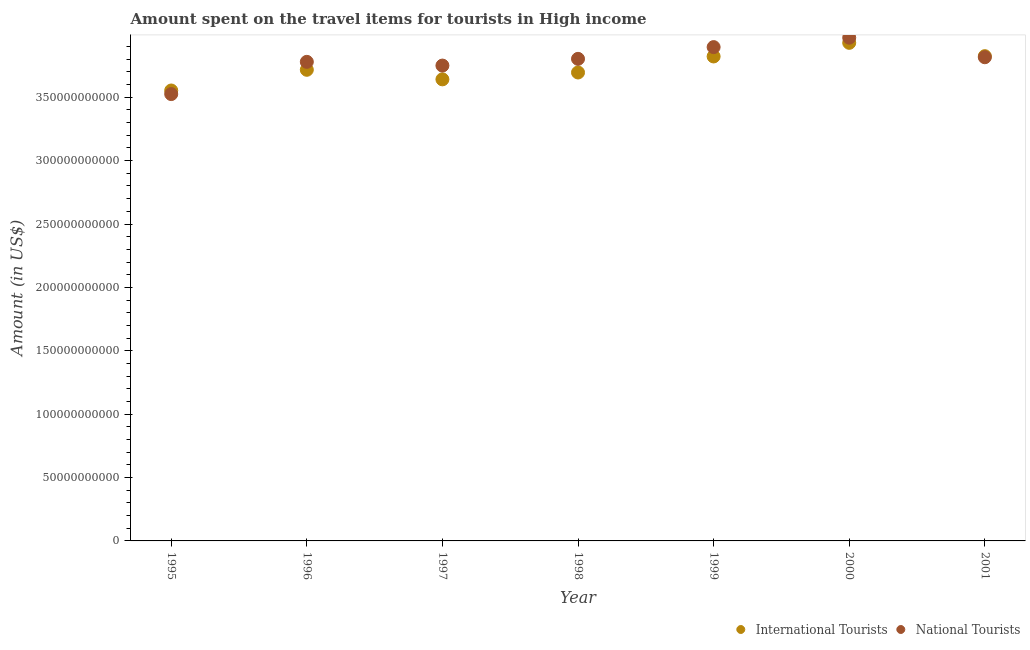How many different coloured dotlines are there?
Provide a short and direct response. 2. Is the number of dotlines equal to the number of legend labels?
Provide a short and direct response. Yes. What is the amount spent on travel items of international tourists in 2000?
Provide a short and direct response. 3.93e+11. Across all years, what is the maximum amount spent on travel items of national tourists?
Give a very brief answer. 3.97e+11. Across all years, what is the minimum amount spent on travel items of national tourists?
Provide a short and direct response. 3.52e+11. In which year was the amount spent on travel items of national tourists minimum?
Give a very brief answer. 1995. What is the total amount spent on travel items of national tourists in the graph?
Your answer should be very brief. 2.65e+12. What is the difference between the amount spent on travel items of international tourists in 1996 and that in 2001?
Make the answer very short. -1.08e+1. What is the difference between the amount spent on travel items of international tourists in 1999 and the amount spent on travel items of national tourists in 1998?
Your answer should be compact. 1.89e+09. What is the average amount spent on travel items of national tourists per year?
Your response must be concise. 3.79e+11. In the year 1998, what is the difference between the amount spent on travel items of international tourists and amount spent on travel items of national tourists?
Offer a very short reply. -1.08e+1. In how many years, is the amount spent on travel items of national tourists greater than 310000000000 US$?
Offer a terse response. 7. What is the ratio of the amount spent on travel items of national tourists in 1999 to that in 2000?
Provide a short and direct response. 0.98. Is the difference between the amount spent on travel items of national tourists in 1995 and 2001 greater than the difference between the amount spent on travel items of international tourists in 1995 and 2001?
Give a very brief answer. No. What is the difference between the highest and the second highest amount spent on travel items of international tourists?
Provide a short and direct response. 1.05e+1. What is the difference between the highest and the lowest amount spent on travel items of national tourists?
Your answer should be very brief. 4.45e+1. Is the sum of the amount spent on travel items of international tourists in 1999 and 2001 greater than the maximum amount spent on travel items of national tourists across all years?
Your answer should be very brief. Yes. Does the amount spent on travel items of international tourists monotonically increase over the years?
Offer a very short reply. No. Is the amount spent on travel items of national tourists strictly greater than the amount spent on travel items of international tourists over the years?
Offer a terse response. No. Is the amount spent on travel items of international tourists strictly less than the amount spent on travel items of national tourists over the years?
Your response must be concise. No. How many dotlines are there?
Give a very brief answer. 2. What is the difference between two consecutive major ticks on the Y-axis?
Ensure brevity in your answer.  5.00e+1. Are the values on the major ticks of Y-axis written in scientific E-notation?
Ensure brevity in your answer.  No. Does the graph contain any zero values?
Your answer should be very brief. No. Does the graph contain grids?
Offer a very short reply. No. How are the legend labels stacked?
Give a very brief answer. Horizontal. What is the title of the graph?
Give a very brief answer. Amount spent on the travel items for tourists in High income. What is the Amount (in US$) in International Tourists in 1995?
Your response must be concise. 3.55e+11. What is the Amount (in US$) in National Tourists in 1995?
Offer a very short reply. 3.52e+11. What is the Amount (in US$) of International Tourists in 1996?
Keep it short and to the point. 3.72e+11. What is the Amount (in US$) in National Tourists in 1996?
Your response must be concise. 3.78e+11. What is the Amount (in US$) in International Tourists in 1997?
Offer a very short reply. 3.64e+11. What is the Amount (in US$) of National Tourists in 1997?
Your answer should be very brief. 3.75e+11. What is the Amount (in US$) of International Tourists in 1998?
Your answer should be very brief. 3.70e+11. What is the Amount (in US$) of National Tourists in 1998?
Provide a succinct answer. 3.80e+11. What is the Amount (in US$) of International Tourists in 1999?
Your response must be concise. 3.82e+11. What is the Amount (in US$) in National Tourists in 1999?
Your response must be concise. 3.90e+11. What is the Amount (in US$) of International Tourists in 2000?
Your answer should be very brief. 3.93e+11. What is the Amount (in US$) in National Tourists in 2000?
Provide a short and direct response. 3.97e+11. What is the Amount (in US$) of International Tourists in 2001?
Your answer should be very brief. 3.82e+11. What is the Amount (in US$) of National Tourists in 2001?
Keep it short and to the point. 3.82e+11. Across all years, what is the maximum Amount (in US$) of International Tourists?
Your response must be concise. 3.93e+11. Across all years, what is the maximum Amount (in US$) in National Tourists?
Your answer should be very brief. 3.97e+11. Across all years, what is the minimum Amount (in US$) of International Tourists?
Make the answer very short. 3.55e+11. Across all years, what is the minimum Amount (in US$) in National Tourists?
Provide a succinct answer. 3.52e+11. What is the total Amount (in US$) of International Tourists in the graph?
Offer a very short reply. 2.62e+12. What is the total Amount (in US$) in National Tourists in the graph?
Your answer should be compact. 2.65e+12. What is the difference between the Amount (in US$) in International Tourists in 1995 and that in 1996?
Offer a very short reply. -1.63e+1. What is the difference between the Amount (in US$) in National Tourists in 1995 and that in 1996?
Ensure brevity in your answer.  -2.54e+1. What is the difference between the Amount (in US$) of International Tourists in 1995 and that in 1997?
Provide a short and direct response. -8.79e+09. What is the difference between the Amount (in US$) of National Tourists in 1995 and that in 1997?
Keep it short and to the point. -2.25e+1. What is the difference between the Amount (in US$) of International Tourists in 1995 and that in 1998?
Keep it short and to the point. -1.42e+1. What is the difference between the Amount (in US$) in National Tourists in 1995 and that in 1998?
Your answer should be compact. -2.78e+1. What is the difference between the Amount (in US$) in International Tourists in 1995 and that in 1999?
Your answer should be very brief. -2.68e+1. What is the difference between the Amount (in US$) in National Tourists in 1995 and that in 1999?
Provide a short and direct response. -3.71e+1. What is the difference between the Amount (in US$) of International Tourists in 1995 and that in 2000?
Keep it short and to the point. -3.76e+1. What is the difference between the Amount (in US$) in National Tourists in 1995 and that in 2000?
Offer a very short reply. -4.45e+1. What is the difference between the Amount (in US$) of International Tourists in 1995 and that in 2001?
Ensure brevity in your answer.  -2.71e+1. What is the difference between the Amount (in US$) in National Tourists in 1995 and that in 2001?
Your answer should be very brief. -2.91e+1. What is the difference between the Amount (in US$) in International Tourists in 1996 and that in 1997?
Offer a very short reply. 7.54e+09. What is the difference between the Amount (in US$) in National Tourists in 1996 and that in 1997?
Your answer should be compact. 2.94e+09. What is the difference between the Amount (in US$) of International Tourists in 1996 and that in 1998?
Your response must be concise. 2.13e+09. What is the difference between the Amount (in US$) in National Tourists in 1996 and that in 1998?
Ensure brevity in your answer.  -2.36e+09. What is the difference between the Amount (in US$) in International Tourists in 1996 and that in 1999?
Offer a very short reply. -1.05e+1. What is the difference between the Amount (in US$) in National Tourists in 1996 and that in 1999?
Your answer should be compact. -1.16e+1. What is the difference between the Amount (in US$) of International Tourists in 1996 and that in 2000?
Provide a succinct answer. -2.13e+1. What is the difference between the Amount (in US$) of National Tourists in 1996 and that in 2000?
Make the answer very short. -1.91e+1. What is the difference between the Amount (in US$) in International Tourists in 1996 and that in 2001?
Your response must be concise. -1.08e+1. What is the difference between the Amount (in US$) in National Tourists in 1996 and that in 2001?
Keep it short and to the point. -3.64e+09. What is the difference between the Amount (in US$) of International Tourists in 1997 and that in 1998?
Provide a short and direct response. -5.41e+09. What is the difference between the Amount (in US$) in National Tourists in 1997 and that in 1998?
Your answer should be very brief. -5.30e+09. What is the difference between the Amount (in US$) in International Tourists in 1997 and that in 1999?
Your answer should be very brief. -1.81e+1. What is the difference between the Amount (in US$) in National Tourists in 1997 and that in 1999?
Offer a very short reply. -1.46e+1. What is the difference between the Amount (in US$) in International Tourists in 1997 and that in 2000?
Offer a terse response. -2.88e+1. What is the difference between the Amount (in US$) in National Tourists in 1997 and that in 2000?
Provide a succinct answer. -2.20e+1. What is the difference between the Amount (in US$) in International Tourists in 1997 and that in 2001?
Your answer should be very brief. -1.83e+1. What is the difference between the Amount (in US$) of National Tourists in 1997 and that in 2001?
Give a very brief answer. -6.58e+09. What is the difference between the Amount (in US$) in International Tourists in 1998 and that in 1999?
Provide a short and direct response. -1.26e+1. What is the difference between the Amount (in US$) of National Tourists in 1998 and that in 1999?
Offer a terse response. -9.26e+09. What is the difference between the Amount (in US$) of International Tourists in 1998 and that in 2000?
Give a very brief answer. -2.34e+1. What is the difference between the Amount (in US$) in National Tourists in 1998 and that in 2000?
Ensure brevity in your answer.  -1.67e+1. What is the difference between the Amount (in US$) of International Tourists in 1998 and that in 2001?
Provide a short and direct response. -1.29e+1. What is the difference between the Amount (in US$) in National Tourists in 1998 and that in 2001?
Ensure brevity in your answer.  -1.28e+09. What is the difference between the Amount (in US$) in International Tourists in 1999 and that in 2000?
Your answer should be very brief. -1.07e+1. What is the difference between the Amount (in US$) of National Tourists in 1999 and that in 2000?
Make the answer very short. -7.43e+09. What is the difference between the Amount (in US$) in International Tourists in 1999 and that in 2001?
Keep it short and to the point. -2.35e+08. What is the difference between the Amount (in US$) in National Tourists in 1999 and that in 2001?
Your response must be concise. 7.99e+09. What is the difference between the Amount (in US$) of International Tourists in 2000 and that in 2001?
Provide a short and direct response. 1.05e+1. What is the difference between the Amount (in US$) of National Tourists in 2000 and that in 2001?
Provide a succinct answer. 1.54e+1. What is the difference between the Amount (in US$) of International Tourists in 1995 and the Amount (in US$) of National Tourists in 1996?
Provide a succinct answer. -2.26e+1. What is the difference between the Amount (in US$) of International Tourists in 1995 and the Amount (in US$) of National Tourists in 1997?
Offer a very short reply. -1.97e+1. What is the difference between the Amount (in US$) of International Tourists in 1995 and the Amount (in US$) of National Tourists in 1998?
Provide a succinct answer. -2.50e+1. What is the difference between the Amount (in US$) in International Tourists in 1995 and the Amount (in US$) in National Tourists in 1999?
Keep it short and to the point. -3.42e+1. What is the difference between the Amount (in US$) in International Tourists in 1995 and the Amount (in US$) in National Tourists in 2000?
Keep it short and to the point. -4.17e+1. What is the difference between the Amount (in US$) in International Tourists in 1995 and the Amount (in US$) in National Tourists in 2001?
Keep it short and to the point. -2.62e+1. What is the difference between the Amount (in US$) in International Tourists in 1996 and the Amount (in US$) in National Tourists in 1997?
Offer a very short reply. -3.33e+09. What is the difference between the Amount (in US$) of International Tourists in 1996 and the Amount (in US$) of National Tourists in 1998?
Your answer should be very brief. -8.63e+09. What is the difference between the Amount (in US$) of International Tourists in 1996 and the Amount (in US$) of National Tourists in 1999?
Your answer should be very brief. -1.79e+1. What is the difference between the Amount (in US$) of International Tourists in 1996 and the Amount (in US$) of National Tourists in 2000?
Provide a short and direct response. -2.53e+1. What is the difference between the Amount (in US$) of International Tourists in 1996 and the Amount (in US$) of National Tourists in 2001?
Your response must be concise. -9.91e+09. What is the difference between the Amount (in US$) of International Tourists in 1997 and the Amount (in US$) of National Tourists in 1998?
Offer a very short reply. -1.62e+1. What is the difference between the Amount (in US$) in International Tourists in 1997 and the Amount (in US$) in National Tourists in 1999?
Your answer should be very brief. -2.54e+1. What is the difference between the Amount (in US$) in International Tourists in 1997 and the Amount (in US$) in National Tourists in 2000?
Provide a succinct answer. -3.29e+1. What is the difference between the Amount (in US$) in International Tourists in 1997 and the Amount (in US$) in National Tourists in 2001?
Give a very brief answer. -1.74e+1. What is the difference between the Amount (in US$) of International Tourists in 1998 and the Amount (in US$) of National Tourists in 1999?
Provide a short and direct response. -2.00e+1. What is the difference between the Amount (in US$) of International Tourists in 1998 and the Amount (in US$) of National Tourists in 2000?
Make the answer very short. -2.75e+1. What is the difference between the Amount (in US$) of International Tourists in 1998 and the Amount (in US$) of National Tourists in 2001?
Provide a short and direct response. -1.20e+1. What is the difference between the Amount (in US$) of International Tourists in 1999 and the Amount (in US$) of National Tourists in 2000?
Your answer should be very brief. -1.48e+1. What is the difference between the Amount (in US$) of International Tourists in 1999 and the Amount (in US$) of National Tourists in 2001?
Offer a terse response. 6.11e+08. What is the difference between the Amount (in US$) in International Tourists in 2000 and the Amount (in US$) in National Tourists in 2001?
Make the answer very short. 1.14e+1. What is the average Amount (in US$) of International Tourists per year?
Make the answer very short. 3.74e+11. What is the average Amount (in US$) of National Tourists per year?
Your response must be concise. 3.79e+11. In the year 1995, what is the difference between the Amount (in US$) in International Tourists and Amount (in US$) in National Tourists?
Your answer should be compact. 2.83e+09. In the year 1996, what is the difference between the Amount (in US$) of International Tourists and Amount (in US$) of National Tourists?
Your response must be concise. -6.27e+09. In the year 1997, what is the difference between the Amount (in US$) of International Tourists and Amount (in US$) of National Tourists?
Keep it short and to the point. -1.09e+1. In the year 1998, what is the difference between the Amount (in US$) in International Tourists and Amount (in US$) in National Tourists?
Offer a very short reply. -1.08e+1. In the year 1999, what is the difference between the Amount (in US$) of International Tourists and Amount (in US$) of National Tourists?
Your answer should be very brief. -7.38e+09. In the year 2000, what is the difference between the Amount (in US$) of International Tourists and Amount (in US$) of National Tourists?
Provide a short and direct response. -4.06e+09. In the year 2001, what is the difference between the Amount (in US$) of International Tourists and Amount (in US$) of National Tourists?
Your answer should be compact. 8.46e+08. What is the ratio of the Amount (in US$) of International Tourists in 1995 to that in 1996?
Offer a very short reply. 0.96. What is the ratio of the Amount (in US$) in National Tourists in 1995 to that in 1996?
Your answer should be compact. 0.93. What is the ratio of the Amount (in US$) in International Tourists in 1995 to that in 1997?
Your answer should be very brief. 0.98. What is the ratio of the Amount (in US$) in International Tourists in 1995 to that in 1998?
Offer a terse response. 0.96. What is the ratio of the Amount (in US$) in National Tourists in 1995 to that in 1998?
Your answer should be compact. 0.93. What is the ratio of the Amount (in US$) in International Tourists in 1995 to that in 1999?
Your response must be concise. 0.93. What is the ratio of the Amount (in US$) in National Tourists in 1995 to that in 1999?
Ensure brevity in your answer.  0.9. What is the ratio of the Amount (in US$) in International Tourists in 1995 to that in 2000?
Give a very brief answer. 0.9. What is the ratio of the Amount (in US$) of National Tourists in 1995 to that in 2000?
Give a very brief answer. 0.89. What is the ratio of the Amount (in US$) of International Tourists in 1995 to that in 2001?
Make the answer very short. 0.93. What is the ratio of the Amount (in US$) in National Tourists in 1995 to that in 2001?
Make the answer very short. 0.92. What is the ratio of the Amount (in US$) in International Tourists in 1996 to that in 1997?
Your answer should be very brief. 1.02. What is the ratio of the Amount (in US$) in National Tourists in 1996 to that in 1997?
Make the answer very short. 1.01. What is the ratio of the Amount (in US$) in International Tourists in 1996 to that in 1999?
Your response must be concise. 0.97. What is the ratio of the Amount (in US$) in National Tourists in 1996 to that in 1999?
Give a very brief answer. 0.97. What is the ratio of the Amount (in US$) of International Tourists in 1996 to that in 2000?
Your response must be concise. 0.95. What is the ratio of the Amount (in US$) in International Tourists in 1996 to that in 2001?
Offer a terse response. 0.97. What is the ratio of the Amount (in US$) of National Tourists in 1996 to that in 2001?
Your answer should be compact. 0.99. What is the ratio of the Amount (in US$) in International Tourists in 1997 to that in 1998?
Offer a terse response. 0.99. What is the ratio of the Amount (in US$) of National Tourists in 1997 to that in 1998?
Your response must be concise. 0.99. What is the ratio of the Amount (in US$) in International Tourists in 1997 to that in 1999?
Offer a very short reply. 0.95. What is the ratio of the Amount (in US$) in National Tourists in 1997 to that in 1999?
Offer a terse response. 0.96. What is the ratio of the Amount (in US$) of International Tourists in 1997 to that in 2000?
Offer a terse response. 0.93. What is the ratio of the Amount (in US$) in National Tourists in 1997 to that in 2000?
Give a very brief answer. 0.94. What is the ratio of the Amount (in US$) in International Tourists in 1997 to that in 2001?
Your answer should be compact. 0.95. What is the ratio of the Amount (in US$) in National Tourists in 1997 to that in 2001?
Keep it short and to the point. 0.98. What is the ratio of the Amount (in US$) of International Tourists in 1998 to that in 1999?
Provide a short and direct response. 0.97. What is the ratio of the Amount (in US$) of National Tourists in 1998 to that in 1999?
Offer a terse response. 0.98. What is the ratio of the Amount (in US$) in International Tourists in 1998 to that in 2000?
Your response must be concise. 0.94. What is the ratio of the Amount (in US$) of National Tourists in 1998 to that in 2000?
Your response must be concise. 0.96. What is the ratio of the Amount (in US$) of International Tourists in 1998 to that in 2001?
Your answer should be very brief. 0.97. What is the ratio of the Amount (in US$) of National Tourists in 1998 to that in 2001?
Your answer should be compact. 1. What is the ratio of the Amount (in US$) of International Tourists in 1999 to that in 2000?
Ensure brevity in your answer.  0.97. What is the ratio of the Amount (in US$) of National Tourists in 1999 to that in 2000?
Your answer should be compact. 0.98. What is the ratio of the Amount (in US$) of National Tourists in 1999 to that in 2001?
Your answer should be very brief. 1.02. What is the ratio of the Amount (in US$) in International Tourists in 2000 to that in 2001?
Offer a very short reply. 1.03. What is the ratio of the Amount (in US$) in National Tourists in 2000 to that in 2001?
Make the answer very short. 1.04. What is the difference between the highest and the second highest Amount (in US$) of International Tourists?
Your answer should be very brief. 1.05e+1. What is the difference between the highest and the second highest Amount (in US$) in National Tourists?
Make the answer very short. 7.43e+09. What is the difference between the highest and the lowest Amount (in US$) of International Tourists?
Your response must be concise. 3.76e+1. What is the difference between the highest and the lowest Amount (in US$) of National Tourists?
Make the answer very short. 4.45e+1. 